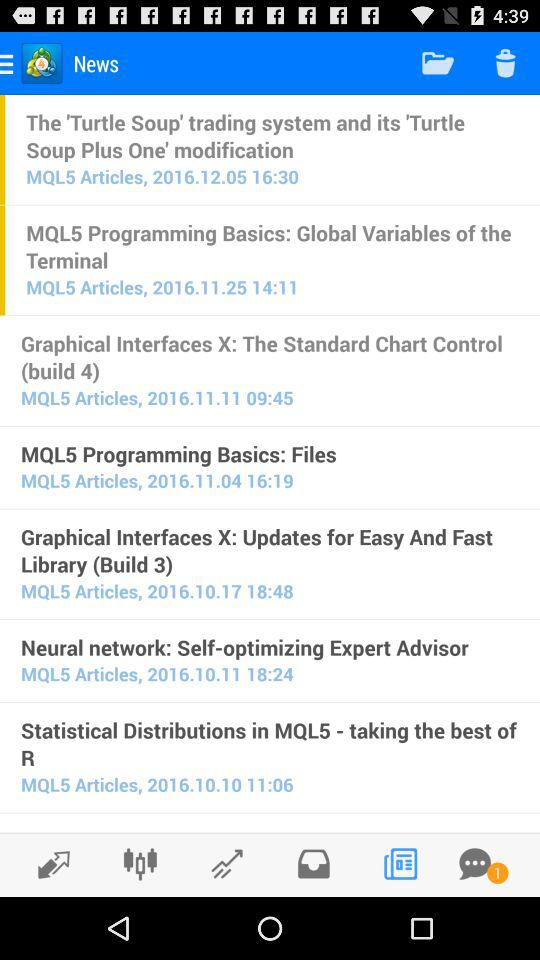Are there any unread messages? There is one unread message. 